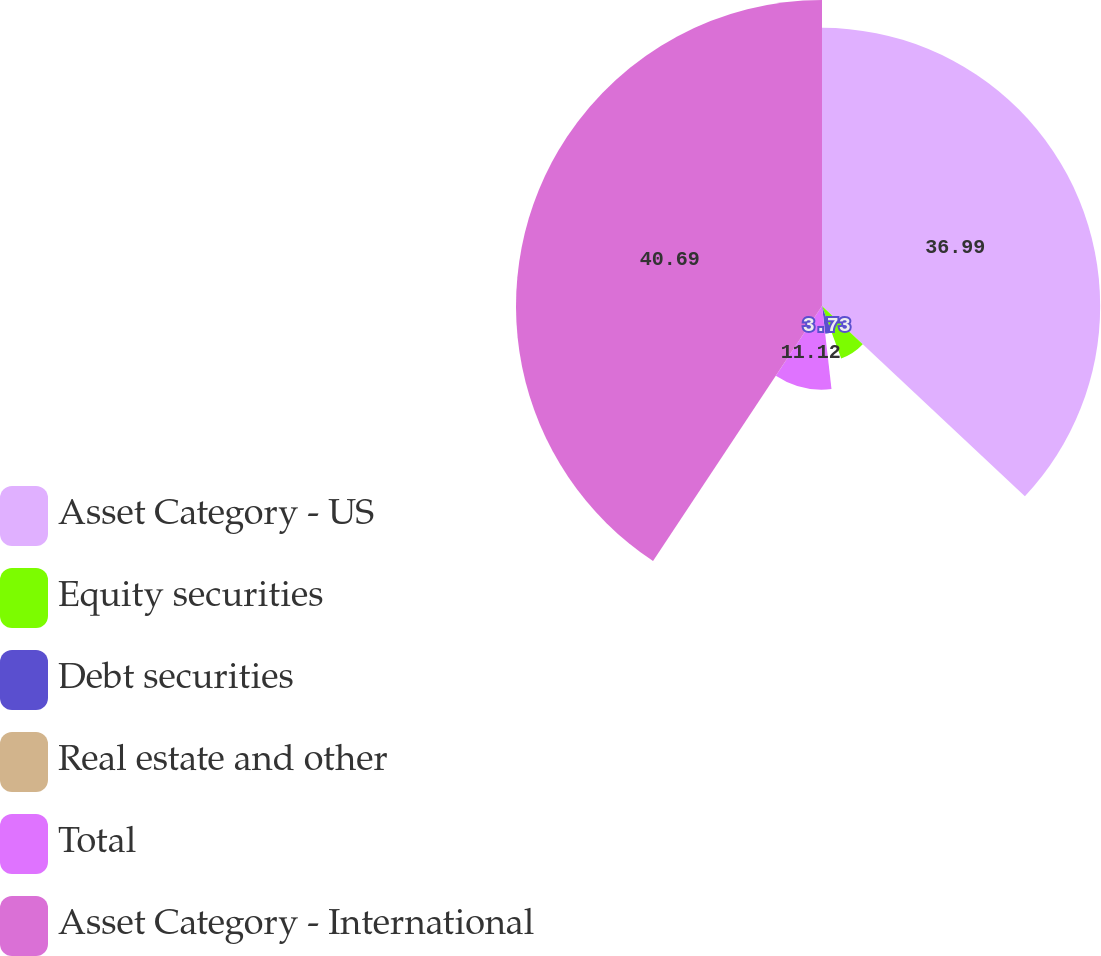Convert chart to OTSL. <chart><loc_0><loc_0><loc_500><loc_500><pie_chart><fcel>Asset Category - US<fcel>Equity securities<fcel>Debt securities<fcel>Real estate and other<fcel>Total<fcel>Asset Category - International<nl><fcel>36.99%<fcel>7.43%<fcel>3.73%<fcel>0.04%<fcel>11.12%<fcel>40.69%<nl></chart> 